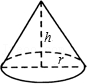What practical applications can this geometric figure have in real life? Cones are widely used in various real-world applications ranging from architectural structures like church spires and rooftops to everyday items like ice cream cones and traffic cones. Additionally, they are crucial in various engineering applications, where understanding the properties of conical shapes helps in designing elements such as funnels, nose cones in rockets, and aerodynamic structures. 